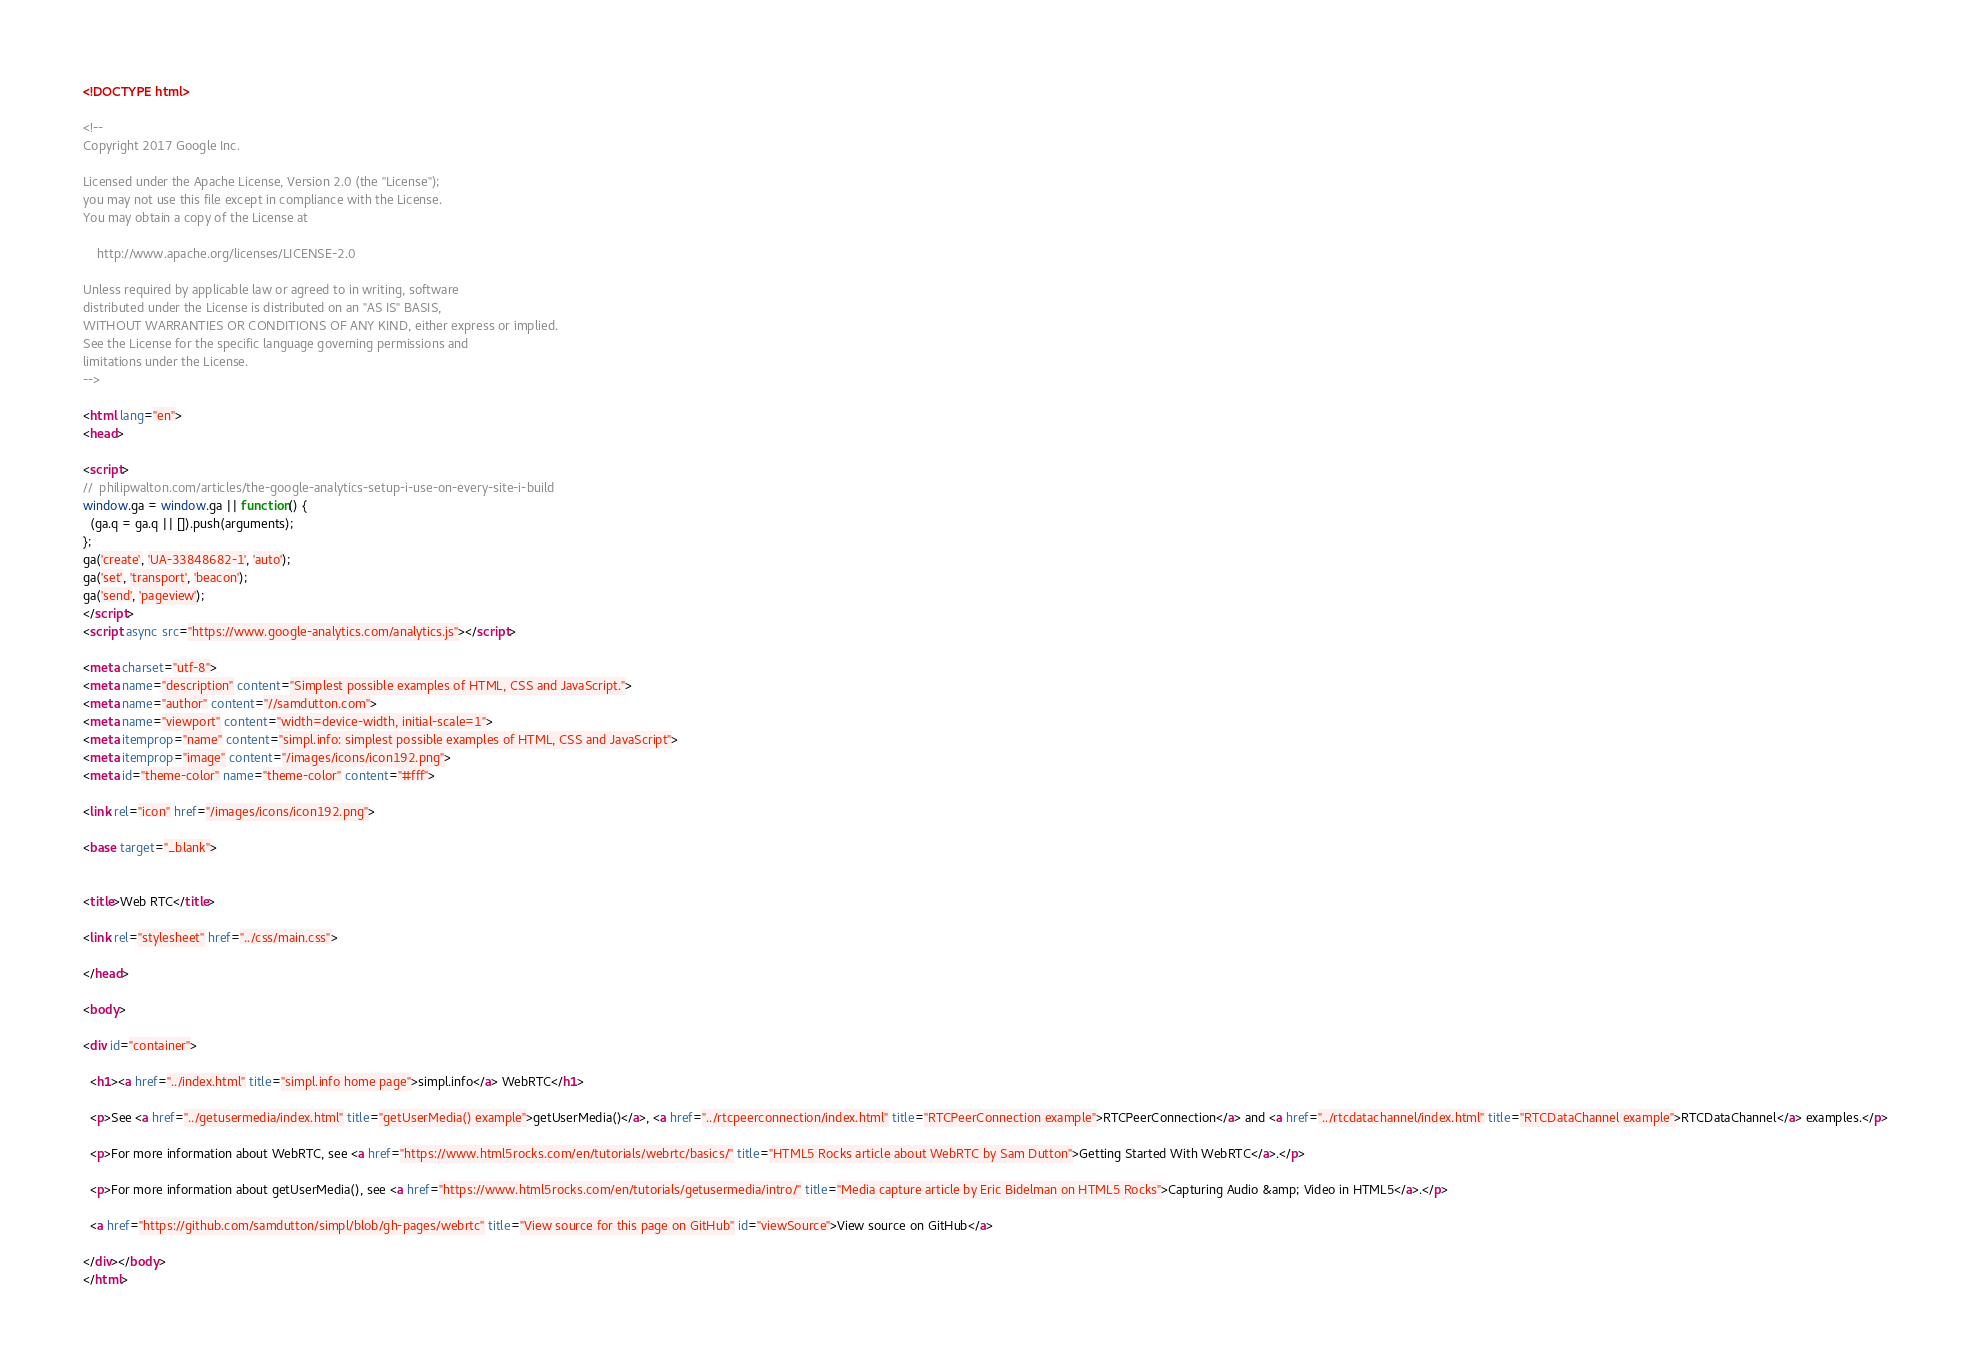Convert code to text. <code><loc_0><loc_0><loc_500><loc_500><_HTML_><!DOCTYPE html>

<!--
Copyright 2017 Google Inc.

Licensed under the Apache License, Version 2.0 (the "License");
you may not use this file except in compliance with the License.
You may obtain a copy of the License at

    http://www.apache.org/licenses/LICENSE-2.0

Unless required by applicable law or agreed to in writing, software
distributed under the License is distributed on an "AS IS" BASIS,
WITHOUT WARRANTIES OR CONDITIONS OF ANY KIND, either express or implied.
See the License for the specific language governing permissions and
limitations under the License.
-->

<html lang="en">
<head>

<script>
//  philipwalton.com/articles/the-google-analytics-setup-i-use-on-every-site-i-build
window.ga = window.ga || function() {
  (ga.q = ga.q || []).push(arguments);
};
ga('create', 'UA-33848682-1', 'auto');
ga('set', 'transport', 'beacon');
ga('send', 'pageview');
</script>
<script async src="https://www.google-analytics.com/analytics.js"></script>

<meta charset="utf-8">
<meta name="description" content="Simplest possible examples of HTML, CSS and JavaScript.">
<meta name="author" content="//samdutton.com">
<meta name="viewport" content="width=device-width, initial-scale=1">
<meta itemprop="name" content="simpl.info: simplest possible examples of HTML, CSS and JavaScript">
<meta itemprop="image" content="/images/icons/icon192.png">
<meta id="theme-color" name="theme-color" content="#fff">

<link rel="icon" href="/images/icons/icon192.png">

<base target="_blank">


<title>Web RTC</title>

<link rel="stylesheet" href="../css/main.css">

</head>

<body>

<div id="container">

  <h1><a href="../index.html" title="simpl.info home page">simpl.info</a> WebRTC</h1>

  <p>See <a href="../getusermedia/index.html" title="getUserMedia() example">getUserMedia()</a>, <a href="../rtcpeerconnection/index.html" title="RTCPeerConnection example">RTCPeerConnection</a> and <a href="../rtcdatachannel/index.html" title="RTCDataChannel example">RTCDataChannel</a> examples.</p>

  <p>For more information about WebRTC, see <a href="https://www.html5rocks.com/en/tutorials/webrtc/basics/" title="HTML5 Rocks article about WebRTC by Sam Dutton">Getting Started With WebRTC</a>.</p>

  <p>For more information about getUserMedia(), see <a href="https://www.html5rocks.com/en/tutorials/getusermedia/intro/" title="Media capture article by Eric Bidelman on HTML5 Rocks">Capturing Audio &amp; Video in HTML5</a>.</p>

  <a href="https://github.com/samdutton/simpl/blob/gh-pages/webrtc" title="View source for this page on GitHub" id="viewSource">View source on GitHub</a>

</div></body>
</html>
</code> 